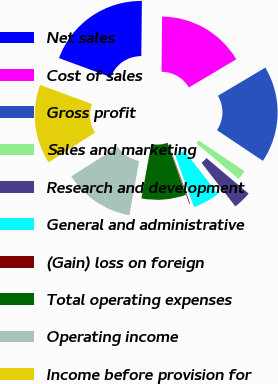Convert chart to OTSL. <chart><loc_0><loc_0><loc_500><loc_500><pie_chart><fcel>Net sales<fcel>Cost of sales<fcel>Gross profit<fcel>Sales and marketing<fcel>Research and development<fcel>General and administrative<fcel>(Gain) loss on foreign<fcel>Total operating expenses<fcel>Operating income<fcel>Income before provision for<nl><fcel>19.54%<fcel>16.3%<fcel>17.92%<fcel>1.76%<fcel>3.37%<fcel>4.99%<fcel>0.14%<fcel>8.22%<fcel>13.07%<fcel>14.69%<nl></chart> 